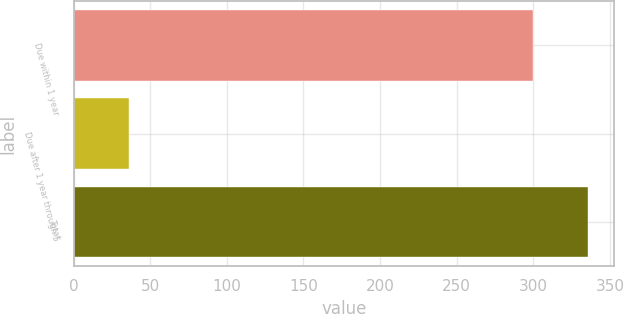Convert chart to OTSL. <chart><loc_0><loc_0><loc_500><loc_500><bar_chart><fcel>Due within 1 year<fcel>Due after 1 year through 5<fcel>Total<nl><fcel>300<fcel>36<fcel>336<nl></chart> 